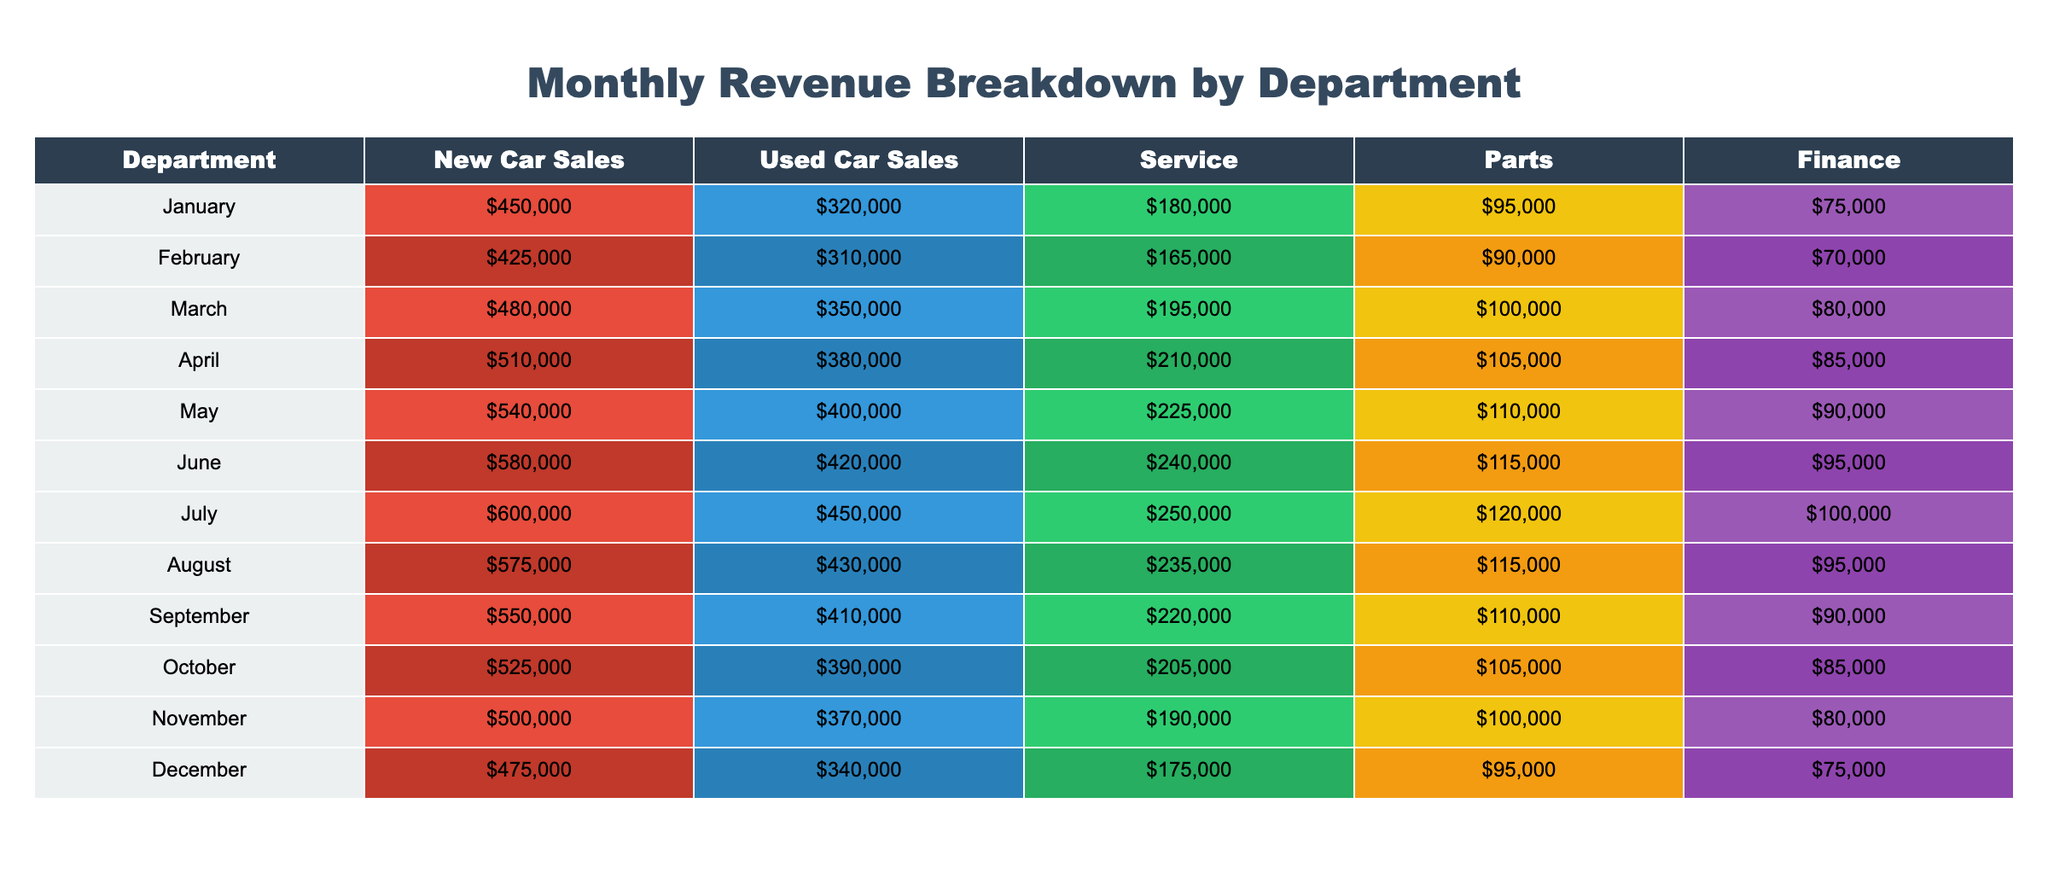What was the highest revenue from New Car Sales in a single month? The highest revenue in the New Car Sales category can be found by scanning through that column. The maximum value is in July, where the revenue was $600000.
Answer: $600000 Which department had the least revenue in December? In December, the revenues for each department are as follows: New Car Sales ($475000), Used Car Sales ($340000), Service ($175000), Parts ($95000), and Finance ($75000). The least revenue comes from the Finance department.
Answer: Finance What was the average revenue from Service over the year? To calculate the average revenue from the Service department over the months, we sum the Service revenues ($180000 + $165000 + $195000 + $210000 + $225000 + $240000 + $250000 + $235000 + $220000 + $205000 + $190000 + $175000 = $2,490,000) and divide by 12, which equals $207500.
Answer: $207500 Was the total revenue from Used Car Sales greater than from Parts in any month? We need to analyze both columns for each month to check if Used Car Sales outperformed Parts. By checking the values, we see every value in Used Car Sales is greater than the corresponding value in Parts. Therefore, the answer is yes.
Answer: Yes What is the difference in revenue between New Car Sales and Used Car Sales in May? In May, New Car Sales revenue is $540000, and Used Car Sales revenue is $400000. The difference can be calculated as $540000 - $400000 = $140000.
Answer: $140000 In which month did the Service department have its highest revenue, and what was the amount? By examining the Service revenue column, we find the highest revenue of $250000 in July.
Answer: July, $250000 Which month saw the least revenue for the Finance department? Looking through the Finance column for each month, the lowest revenue amount was $75000 in December.
Answer: December, $75000 What was the total revenue from Parts for the entire year? We sum the Parts revenue across all months: ($95000 + $90000 + $100000 + $105000 + $110000 + $115000 + $120000 + $115000 + $110000 + $105000 + $100000 + $95000 = $1,285,000).
Answer: $1,285,000 